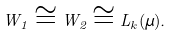<formula> <loc_0><loc_0><loc_500><loc_500>W _ { 1 } \cong W _ { 2 } \cong L _ { k } ( \mu ) .</formula> 